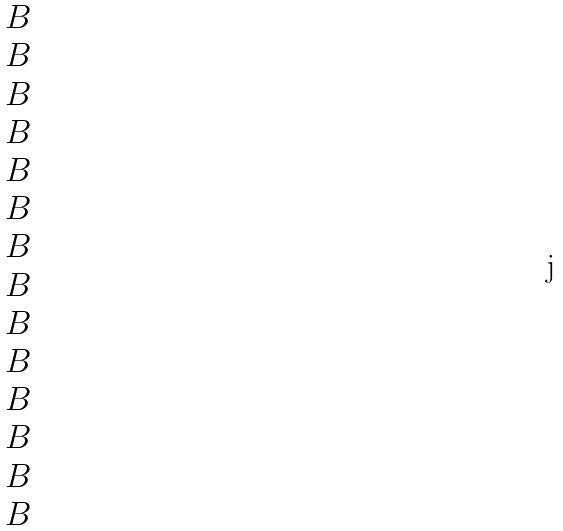Convert formula to latex. <formula><loc_0><loc_0><loc_500><loc_500>\begin{matrix} B \\ B \\ B \\ B \\ B \\ B \\ B \\ B \\ B \\ B \\ B \\ B \\ B \\ B \end{matrix}</formula> 